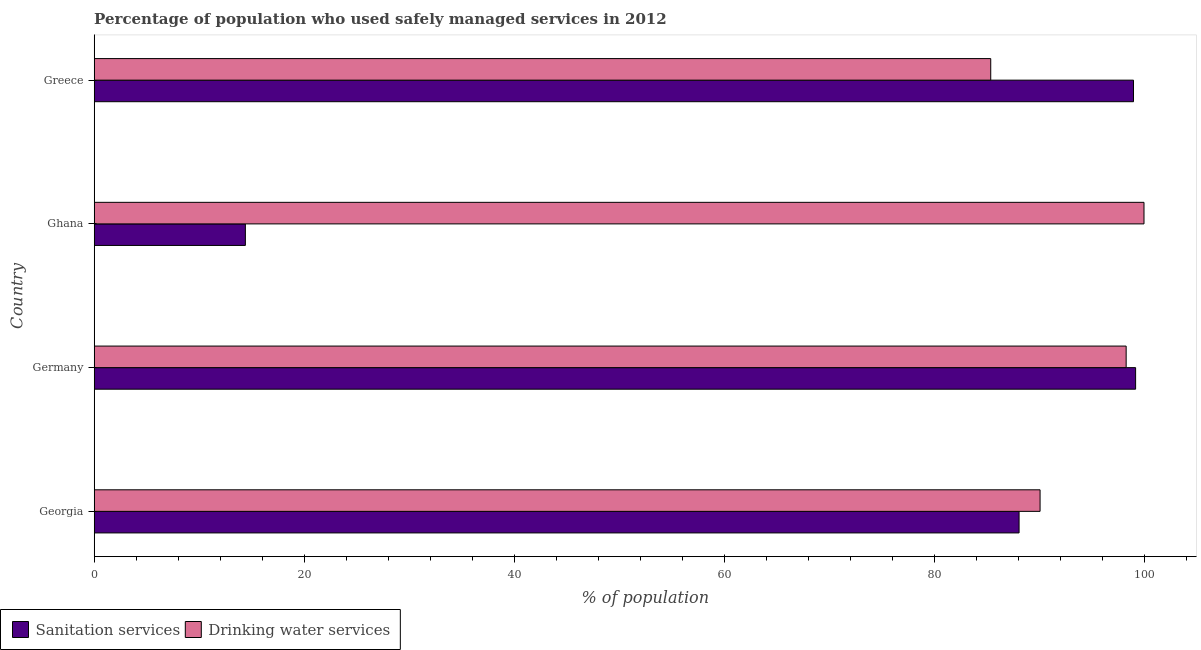How many groups of bars are there?
Your answer should be very brief. 4. Are the number of bars per tick equal to the number of legend labels?
Provide a short and direct response. Yes. How many bars are there on the 3rd tick from the top?
Give a very brief answer. 2. In how many cases, is the number of bars for a given country not equal to the number of legend labels?
Your answer should be very brief. 0. What is the percentage of population who used drinking water services in Germany?
Make the answer very short. 98.3. Across all countries, what is the maximum percentage of population who used sanitation services?
Your response must be concise. 99.2. Across all countries, what is the minimum percentage of population who used drinking water services?
Your answer should be compact. 85.4. In which country was the percentage of population who used sanitation services minimum?
Ensure brevity in your answer.  Ghana. What is the total percentage of population who used sanitation services in the graph?
Ensure brevity in your answer.  300.7. What is the difference between the percentage of population who used sanitation services in Ghana and the percentage of population who used drinking water services in Germany?
Keep it short and to the point. -83.9. What is the average percentage of population who used drinking water services per country?
Your answer should be compact. 93.45. What is the difference between the percentage of population who used drinking water services and percentage of population who used sanitation services in Ghana?
Your answer should be very brief. 85.6. What is the ratio of the percentage of population who used drinking water services in Ghana to that in Greece?
Provide a succinct answer. 1.17. Is the percentage of population who used sanitation services in Georgia less than that in Greece?
Ensure brevity in your answer.  Yes. Is the difference between the percentage of population who used drinking water services in Georgia and Ghana greater than the difference between the percentage of population who used sanitation services in Georgia and Ghana?
Your answer should be compact. No. In how many countries, is the percentage of population who used sanitation services greater than the average percentage of population who used sanitation services taken over all countries?
Your answer should be compact. 3. What does the 1st bar from the top in Greece represents?
Give a very brief answer. Drinking water services. What does the 2nd bar from the bottom in Georgia represents?
Keep it short and to the point. Drinking water services. How many countries are there in the graph?
Give a very brief answer. 4. Does the graph contain grids?
Your answer should be compact. No. Where does the legend appear in the graph?
Offer a terse response. Bottom left. How are the legend labels stacked?
Offer a very short reply. Horizontal. What is the title of the graph?
Offer a very short reply. Percentage of population who used safely managed services in 2012. What is the label or title of the X-axis?
Ensure brevity in your answer.  % of population. What is the % of population of Sanitation services in Georgia?
Your answer should be compact. 88.1. What is the % of population of Drinking water services in Georgia?
Your answer should be compact. 90.1. What is the % of population of Sanitation services in Germany?
Give a very brief answer. 99.2. What is the % of population in Drinking water services in Germany?
Ensure brevity in your answer.  98.3. What is the % of population of Sanitation services in Greece?
Your answer should be compact. 99. What is the % of population of Drinking water services in Greece?
Offer a terse response. 85.4. Across all countries, what is the maximum % of population of Sanitation services?
Your answer should be compact. 99.2. Across all countries, what is the minimum % of population in Drinking water services?
Your response must be concise. 85.4. What is the total % of population of Sanitation services in the graph?
Provide a succinct answer. 300.7. What is the total % of population of Drinking water services in the graph?
Your answer should be very brief. 373.8. What is the difference between the % of population in Sanitation services in Georgia and that in Ghana?
Make the answer very short. 73.7. What is the difference between the % of population of Sanitation services in Germany and that in Ghana?
Make the answer very short. 84.8. What is the difference between the % of population in Sanitation services in Germany and that in Greece?
Give a very brief answer. 0.2. What is the difference between the % of population in Drinking water services in Germany and that in Greece?
Provide a succinct answer. 12.9. What is the difference between the % of population in Sanitation services in Ghana and that in Greece?
Offer a terse response. -84.6. What is the difference between the % of population of Sanitation services in Georgia and the % of population of Drinking water services in Germany?
Your response must be concise. -10.2. What is the difference between the % of population in Sanitation services in Georgia and the % of population in Drinking water services in Greece?
Your answer should be very brief. 2.7. What is the difference between the % of population in Sanitation services in Germany and the % of population in Drinking water services in Ghana?
Give a very brief answer. -0.8. What is the difference between the % of population in Sanitation services in Ghana and the % of population in Drinking water services in Greece?
Ensure brevity in your answer.  -71. What is the average % of population in Sanitation services per country?
Give a very brief answer. 75.17. What is the average % of population of Drinking water services per country?
Give a very brief answer. 93.45. What is the difference between the % of population in Sanitation services and % of population in Drinking water services in Ghana?
Provide a succinct answer. -85.6. What is the ratio of the % of population in Sanitation services in Georgia to that in Germany?
Keep it short and to the point. 0.89. What is the ratio of the % of population of Drinking water services in Georgia to that in Germany?
Your response must be concise. 0.92. What is the ratio of the % of population of Sanitation services in Georgia to that in Ghana?
Provide a succinct answer. 6.12. What is the ratio of the % of population of Drinking water services in Georgia to that in Ghana?
Keep it short and to the point. 0.9. What is the ratio of the % of population of Sanitation services in Georgia to that in Greece?
Ensure brevity in your answer.  0.89. What is the ratio of the % of population in Drinking water services in Georgia to that in Greece?
Give a very brief answer. 1.05. What is the ratio of the % of population of Sanitation services in Germany to that in Ghana?
Your response must be concise. 6.89. What is the ratio of the % of population of Sanitation services in Germany to that in Greece?
Offer a very short reply. 1. What is the ratio of the % of population in Drinking water services in Germany to that in Greece?
Give a very brief answer. 1.15. What is the ratio of the % of population of Sanitation services in Ghana to that in Greece?
Keep it short and to the point. 0.15. What is the ratio of the % of population of Drinking water services in Ghana to that in Greece?
Offer a terse response. 1.17. What is the difference between the highest and the second highest % of population of Sanitation services?
Your response must be concise. 0.2. What is the difference between the highest and the lowest % of population in Sanitation services?
Offer a very short reply. 84.8. What is the difference between the highest and the lowest % of population in Drinking water services?
Your response must be concise. 14.6. 